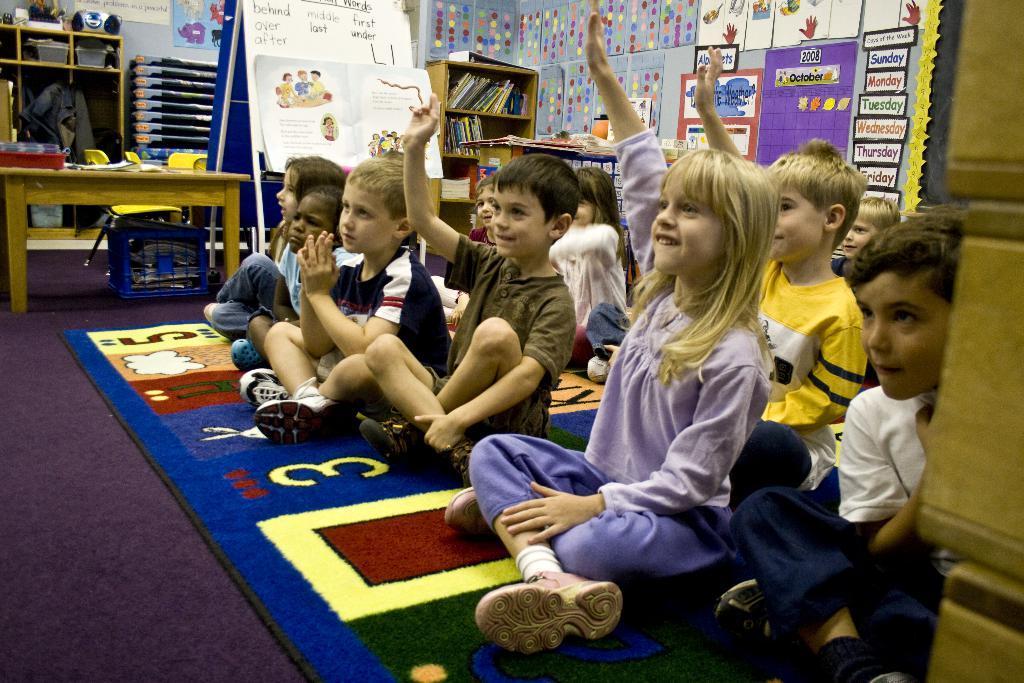How would you summarize this image in a sentence or two? There are some children sitting on a carpet. In the back there is a table. On that there are many items. Also there is a board with something written on that. There is a cupboard inside that there are books. Also there is a wall with many things on that. 